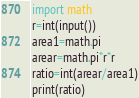Convert code to text. <code><loc_0><loc_0><loc_500><loc_500><_Python_>import math
r=int(input())
area1=math.pi
arear=math.pi*r*r
ratio=int(arear/area1)
print(ratio)</code> 